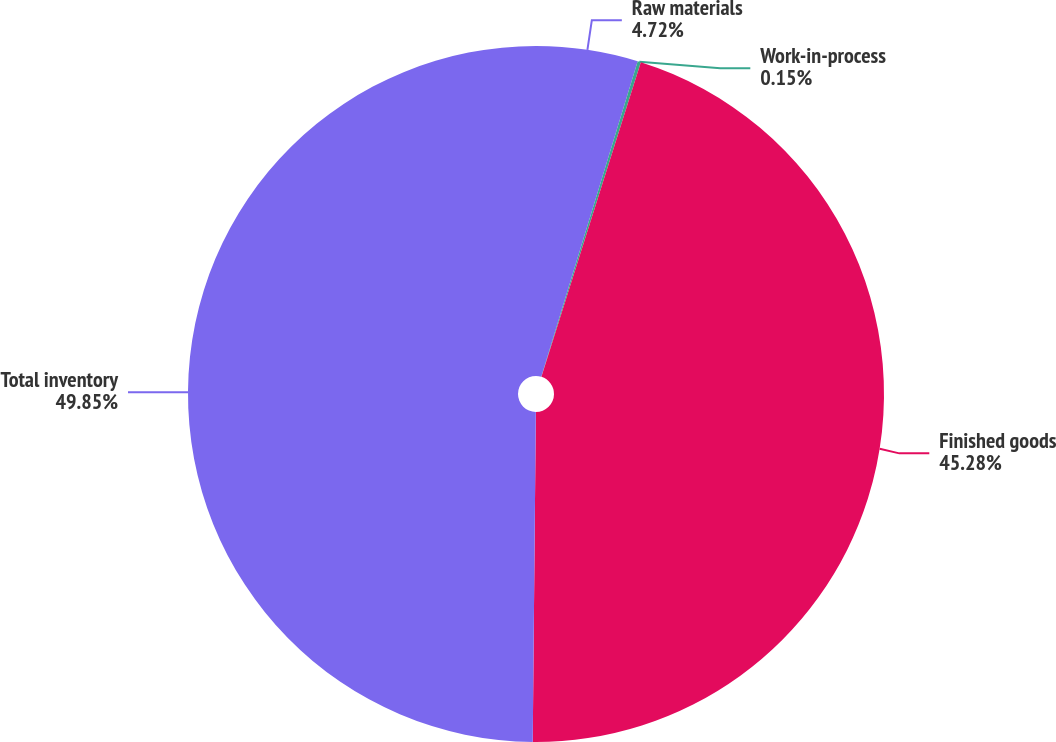Convert chart. <chart><loc_0><loc_0><loc_500><loc_500><pie_chart><fcel>Raw materials<fcel>Work-in-process<fcel>Finished goods<fcel>Total inventory<nl><fcel>4.72%<fcel>0.15%<fcel>45.28%<fcel>49.85%<nl></chart> 